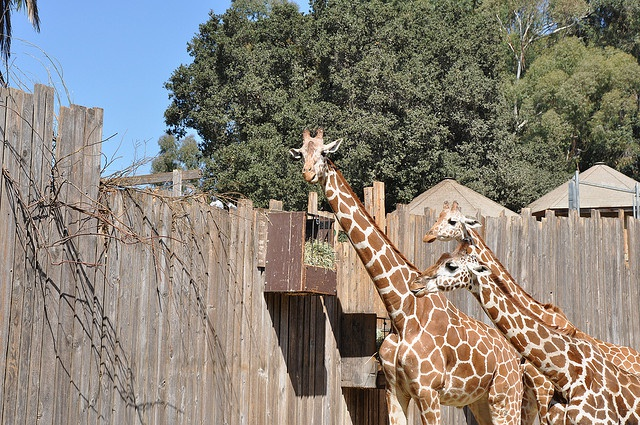Describe the objects in this image and their specific colors. I can see giraffe in black, white, gray, brown, and tan tones, giraffe in black, white, gray, brown, and maroon tones, and giraffe in black, white, tan, and gray tones in this image. 